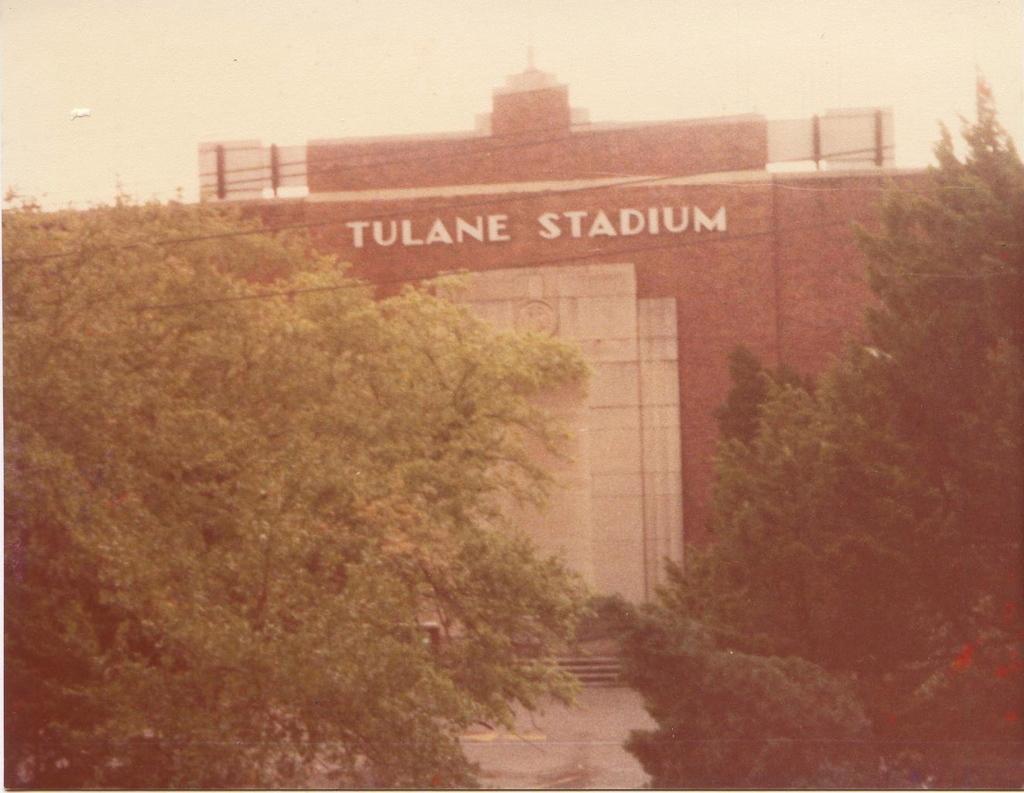Please provide a concise description of this image. A picture of a "Tulane stadium". This stadium walls are in red color and white color. In-front of this stadium there are trees. 